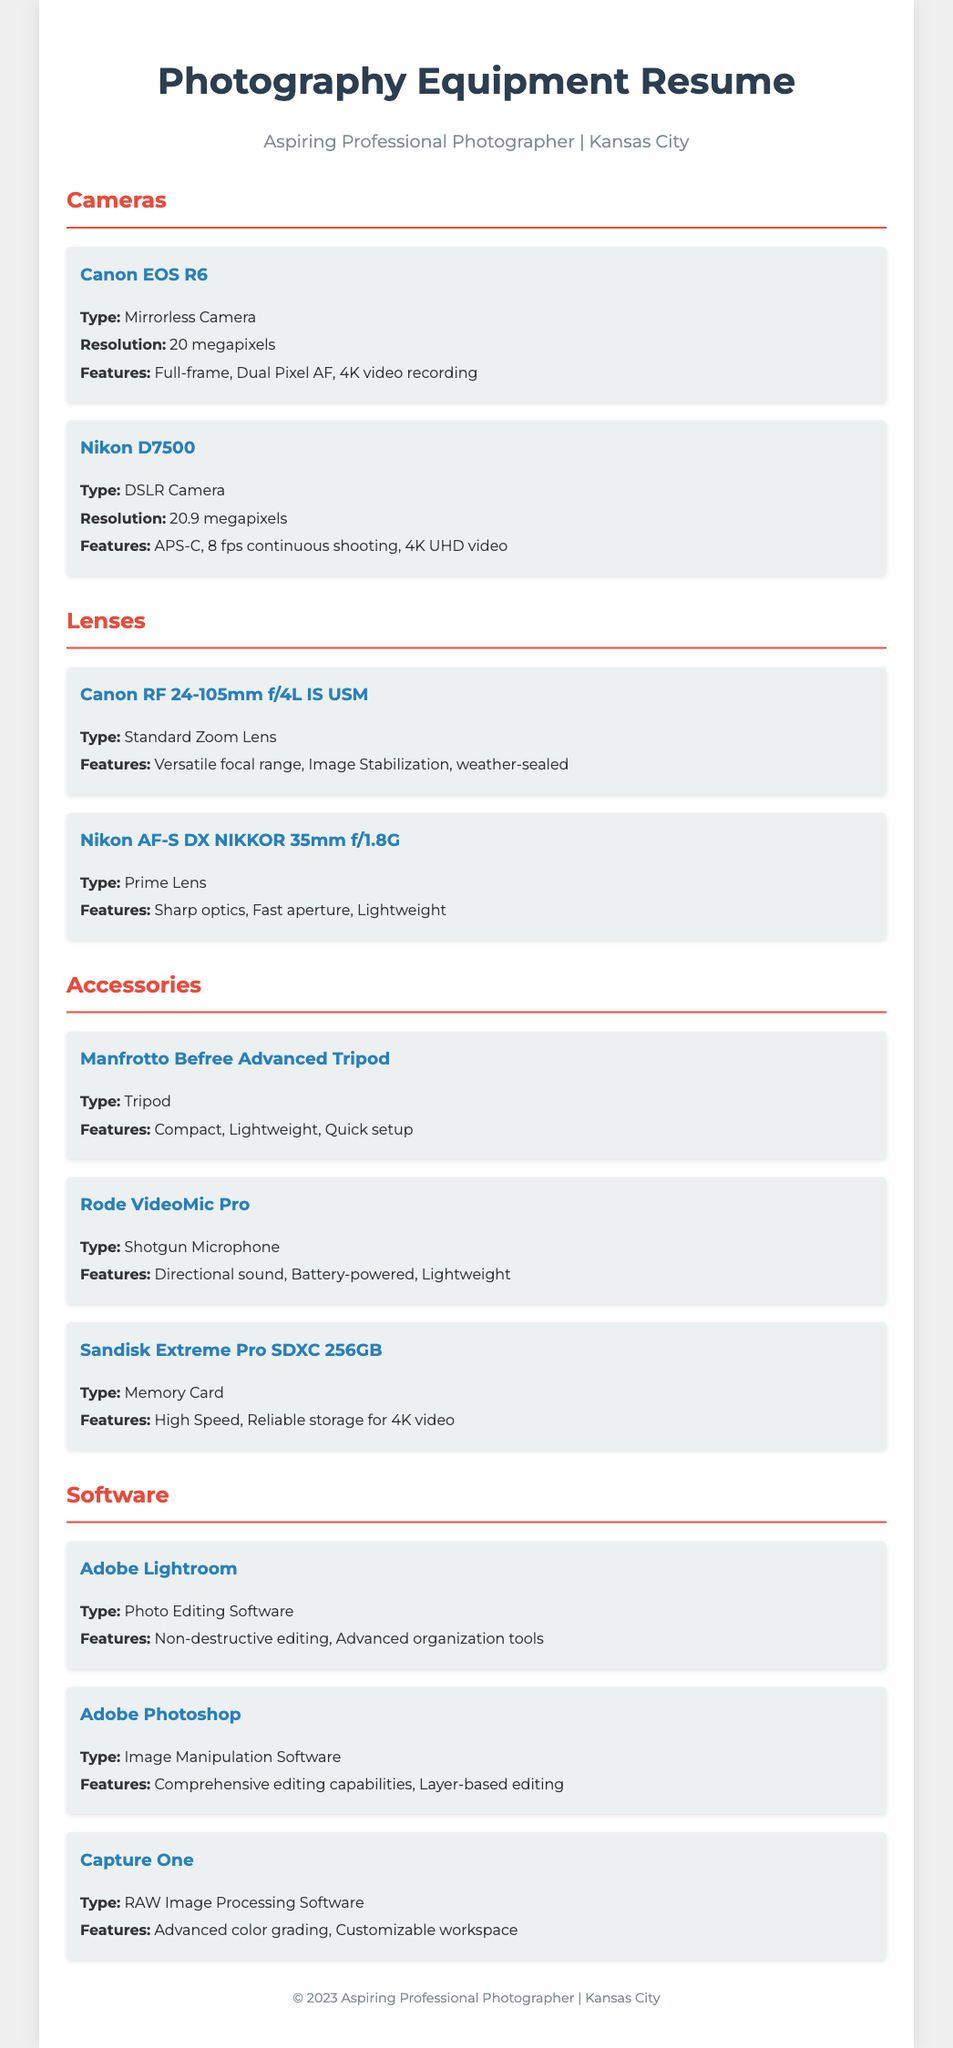what model of mirrorless camera is listed? The document mentions the Canon EOS R6 as the mirrorless camera.
Answer: Canon EOS R6 how many lenses are listed in the document? The document lists a total of two lenses under the Lenses section.
Answer: 2 what type of software is Adobe Lightroom categorized as? According to the document, Adobe Lightroom is categorized as photo editing software.
Answer: Photo Editing Software what is the resolution of the Nikon D7500? The document states that the Nikon D7500 has a resolution of 20.9 megapixels.
Answer: 20.9 megapixels which microphone is included in the accessories? The document includes the Rode VideoMic Pro under the accessories section.
Answer: Rode VideoMic Pro which camera has 4K video recording features? The Canon EOS R6 is mentioned to have 4K video recording features.
Answer: Canon EOS R6 what is the focal length of the Nikon AF-S DX NIKKOR lens? The document specifies that the focal length of the Nikon AF-S DX NIKKOR lens is 35mm.
Answer: 35mm what feature is highlighted for the Manfrotto Befree Advanced Tripod? The document notes that the Manfrotto Befree Advanced Tripod is compact.
Answer: Compact what is the highest resolution camera listed? The document lists the Nikon D7500 with the highest resolution of 20.9 megapixels.
Answer: Nikon D7500 